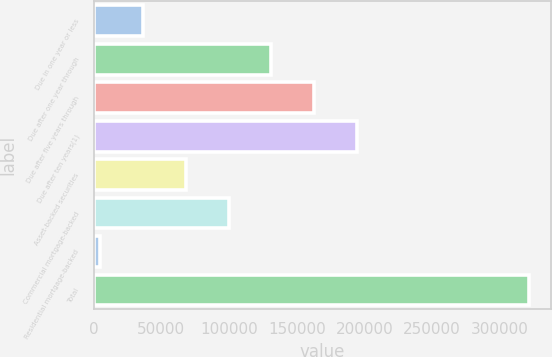Convert chart to OTSL. <chart><loc_0><loc_0><loc_500><loc_500><bar_chart><fcel>Due in one year or less<fcel>Due after one year through<fcel>Due after five years through<fcel>Due after ten years(1)<fcel>Asset-backed securities<fcel>Commercial mortgage-backed<fcel>Residential mortgage-backed<fcel>Total<nl><fcel>36220.7<fcel>131287<fcel>162976<fcel>194664<fcel>67909.4<fcel>99598.1<fcel>4532<fcel>321419<nl></chart> 